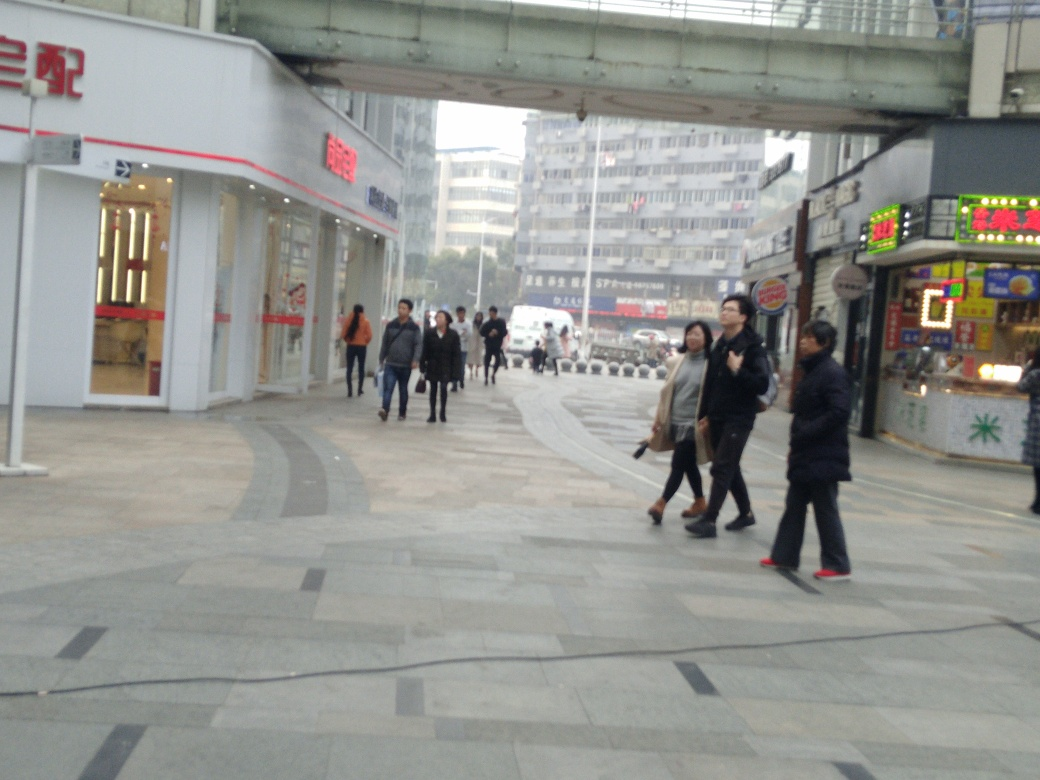What sort of businesses can be seen in the image? The image shows a variety of storefronts including what appears to be a food establishment, indicated by the sign that resembles food-related icons, and possibly a retail or convenience store. There's also signage that is not in English, which suggests diverse cultural influences or a non-English-speaking region. 